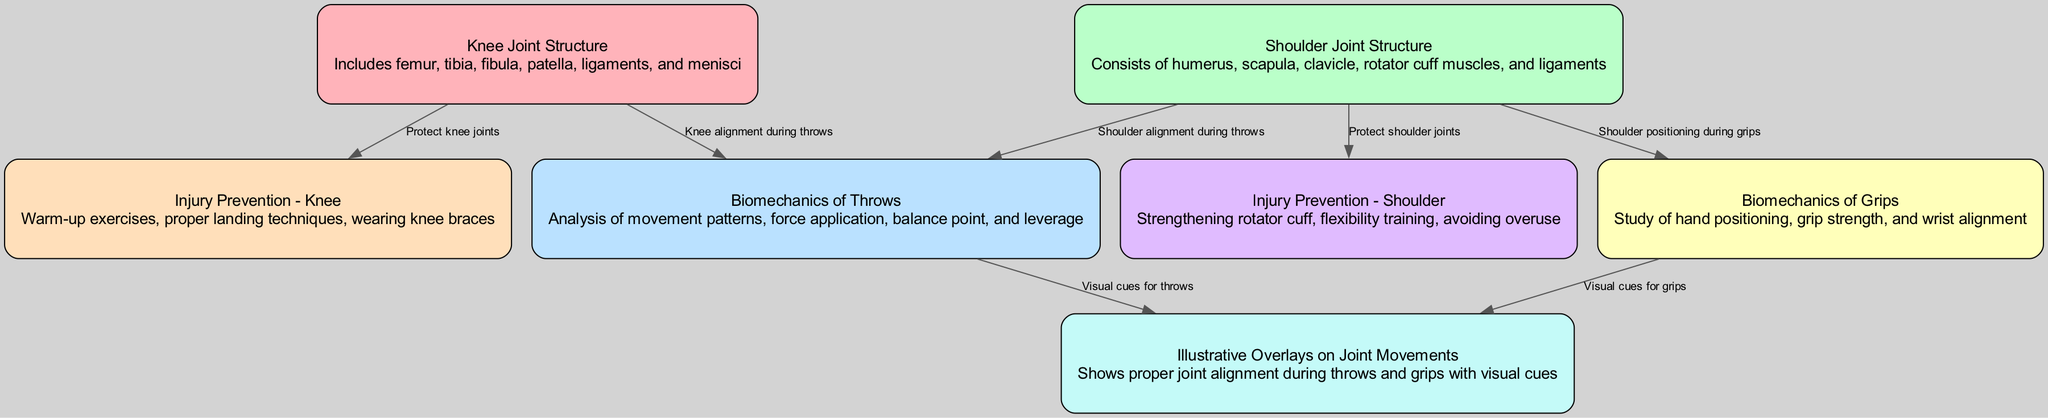What structures are included in the knee joint structure? The knee joint structure node lists the components as femur, tibia, fibula, patella, ligaments, and menisci directly in the description provided for that node.
Answer: femur, tibia, fibula, patella, ligaments, menisci How many nodes are present in the diagram? By counting the nodes listed in the data, there are a total of seven distinct nodes.
Answer: 7 What connects the knee joint structure to injury prevention for the knee? There is a direct edge labeled "Protect knee joints" that links the knee joint structure node to the injury prevention for the knee node, indicating their relationship.
Answer: Protect knee joints Which joint structure is associated with injury prevention measures for the shoulder? The shoulder joint structure node directly connects to the injury prevention for the shoulder node with the edge labeled "Protect shoulder joints," showing their association.
Answer: Protect shoulder joints What type of movement does the biomechanics of throws analyze? The biomechanics of throws node describes the analysis of movement patterns, force application, balance point, and leverage, which collectively summarize the specific actions involved in throwing.
Answer: Movement patterns, force application, balance point, leverage What are the preventative measures listed for knee injury prevention? The injury prevention for the knee node describes the preventative measures as warm-up exercises, proper landing techniques, and wearing knee braces, which are critical for protecting the knee during judo activities.
Answer: Warm-up exercises, proper landing techniques, knee braces How do illustrative overlays contribute to understanding joint movements? The overlays joint movements node indicates that it provides visual cues for proper joint alignment during throws and grips, enhancing the understanding of how to execute these movements without injury.
Answer: Visual cues for proper joint alignment Which joint structure is involved in gripping mechanics? The shoulder joint structure node is linked to the biomechanics of grips node, indicating that shoulder positioning during grips is essential for effective gripping mechanics.
Answer: Shoulder joint structure 